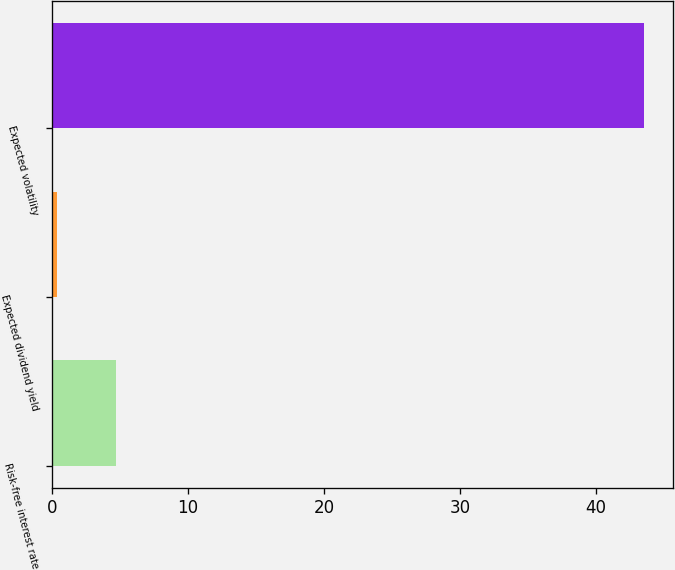<chart> <loc_0><loc_0><loc_500><loc_500><bar_chart><fcel>Risk-free interest rate<fcel>Expected dividend yield<fcel>Expected volatility<nl><fcel>4.71<fcel>0.4<fcel>43.5<nl></chart> 